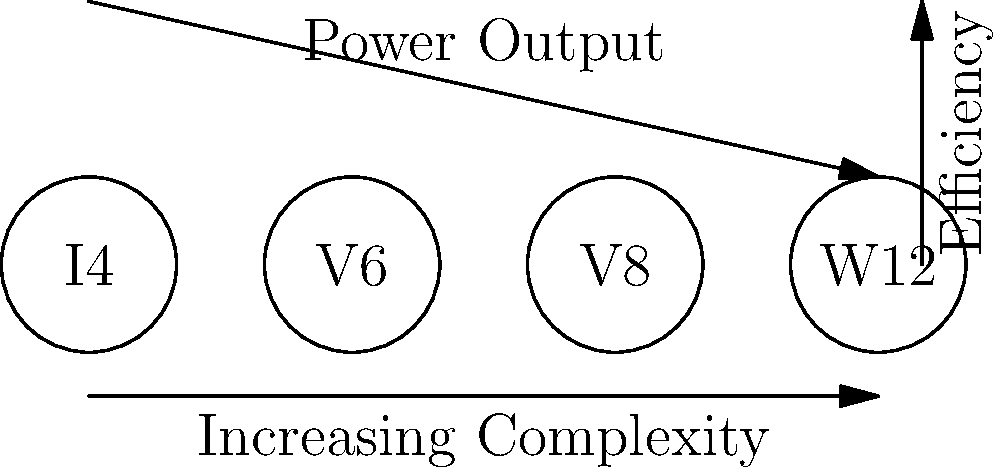In the diagram above, four different engine layouts are shown: I4, V6, V8, and W12. Based on your knowledge of car engines and the trends indicated by the arrows, which engine layout would likely offer the best balance between efficiency and power output for a high-performance sports car? To determine the best engine layout for a high-performance sports car, we need to consider the balance between efficiency and power output:

1. The horizontal arrow indicates increasing complexity from left to right (I4 → V6 → V8 → W12).
2. The vertical arrow on the right shows that efficiency generally decreases as we move up the complexity scale.
3. The diagonal arrow indicates that power output increases with complexity.

Step-by-step analysis:
1. I4 (Inline-4): Highest efficiency but lowest power output.
2. V6: Good balance between efficiency and power, more compact than I4.
3. V8: Higher power output than V6, slightly lower efficiency, popular in sports cars.
4. W12: Highest power output but lowest efficiency, more suitable for luxury vehicles.

For a high-performance sports car, we need a good balance of power and efficiency. The V8 engine offers a compelling combination:
- It provides significantly more power than an I4 or V6.
- It maintains better efficiency than a W12.
- V8 engines are commonly used in sports cars due to their excellent power-to-weight ratio.

While a V6 could also be a good choice, the V8's additional power makes it more suitable for high-performance applications without the extreme complexity and inefficiency of a W12.
Answer: V8 